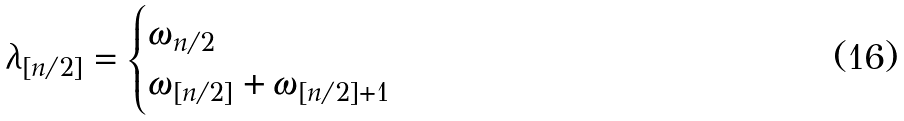Convert formula to latex. <formula><loc_0><loc_0><loc_500><loc_500>\lambda _ { [ n / 2 ] } = \begin{cases} \omega _ { n / 2 } & \\ \omega _ { [ n / 2 ] } + \omega _ { [ n / 2 ] + 1 } & \end{cases}</formula> 